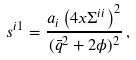<formula> <loc_0><loc_0><loc_500><loc_500>s ^ { i 1 } = \frac { a _ { i } \left ( 4 x \Sigma ^ { i i } \right ) ^ { 2 } } { ( \bar { q } ^ { 2 } + 2 \phi ) ^ { 2 } } \, ,</formula> 